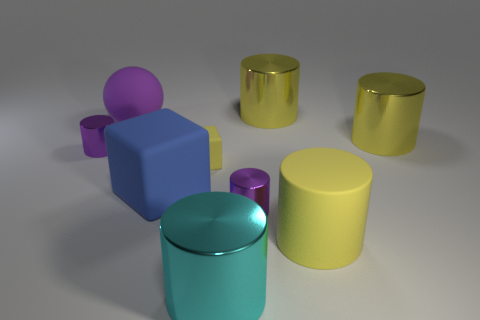There is a cyan cylinder that is the same size as the blue object; what is it made of?
Keep it short and to the point. Metal. Is the size of the purple shiny cylinder right of the big cyan object the same as the blue thing in front of the big purple rubber sphere?
Your response must be concise. No. There is a large cyan thing; are there any big cylinders behind it?
Provide a succinct answer. Yes. What color is the large metallic thing behind the yellow cylinder that is to the right of the large matte cylinder?
Your answer should be very brief. Yellow. Is the number of spheres less than the number of large cylinders?
Provide a short and direct response. Yes. How many yellow metallic objects are the same shape as the big cyan metallic thing?
Your response must be concise. 2. There is a rubber cylinder that is the same size as the purple matte object; what is its color?
Your answer should be compact. Yellow. Is the number of yellow metal objects that are to the right of the rubber cylinder the same as the number of big yellow matte things that are in front of the yellow rubber block?
Offer a terse response. Yes. Are there any blue things that have the same size as the purple matte object?
Ensure brevity in your answer.  Yes. What size is the blue block?
Your answer should be compact. Large. 